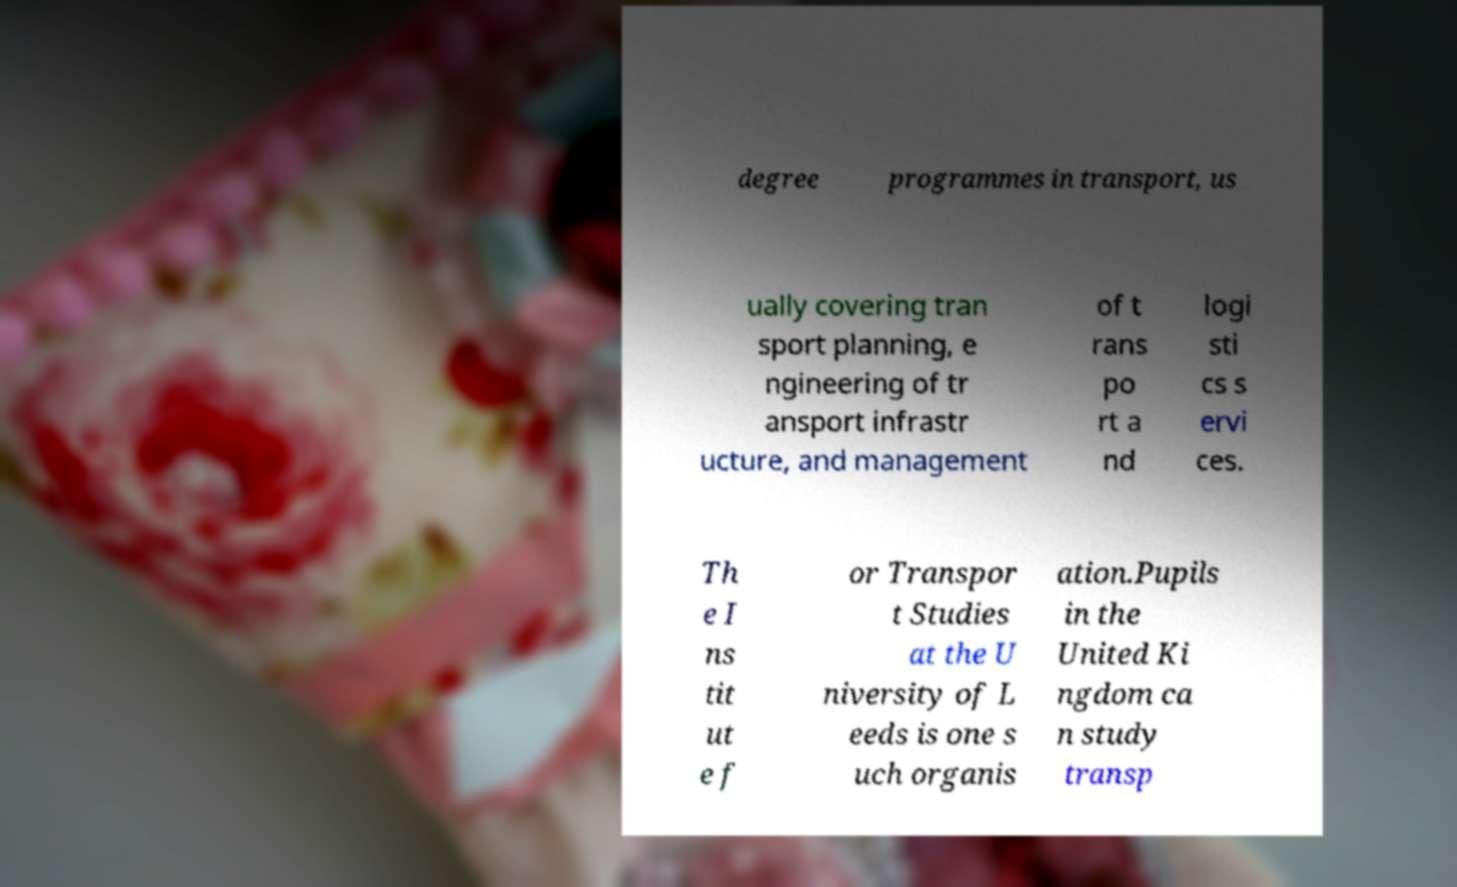I need the written content from this picture converted into text. Can you do that? degree programmes in transport, us ually covering tran sport planning, e ngineering of tr ansport infrastr ucture, and management of t rans po rt a nd logi sti cs s ervi ces. Th e I ns tit ut e f or Transpor t Studies at the U niversity of L eeds is one s uch organis ation.Pupils in the United Ki ngdom ca n study transp 